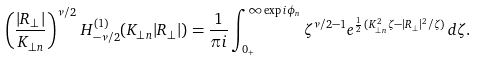<formula> <loc_0><loc_0><loc_500><loc_500>\left ( \frac { | R _ { \perp } | } { K _ { \perp n } } \right ) ^ { \nu / 2 } \, H _ { - \nu / 2 } ^ { ( 1 ) } ( K _ { \perp n } | R _ { \perp } | ) = \frac { 1 } { \pi i } \int _ { 0 _ { + } } ^ { \infty \exp { i \phi _ { n } } } \zeta ^ { \nu / 2 - 1 } e ^ { \frac { 1 } { 2 } \, ( K _ { \perp n } ^ { 2 } \zeta - | R _ { \perp } | ^ { 2 } / \zeta ) } \, d \zeta .</formula> 